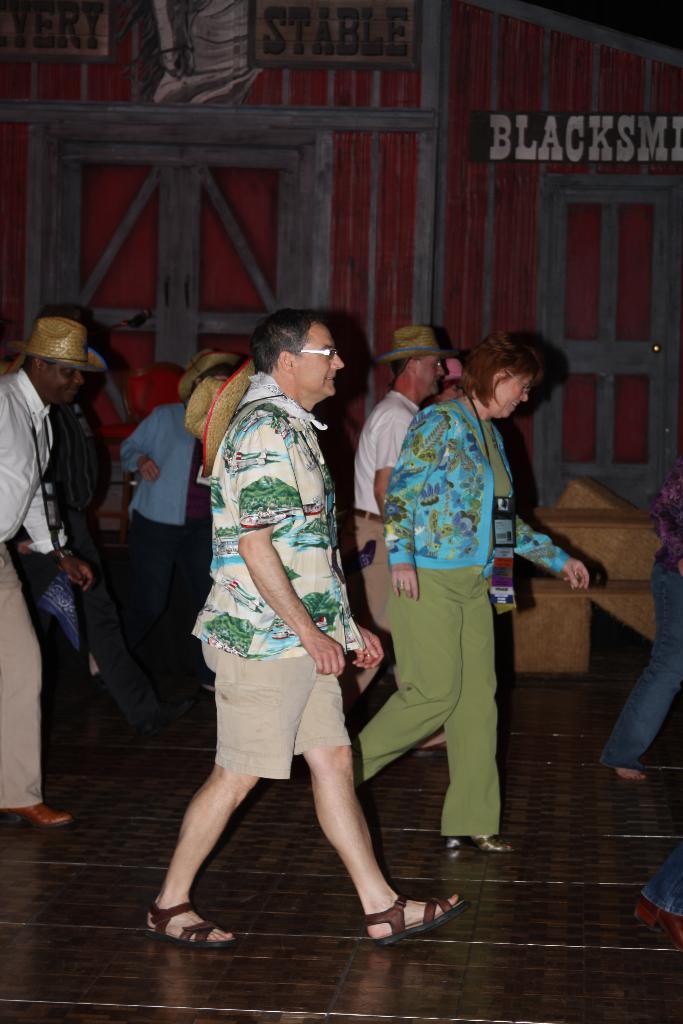Could you give a brief overview of what you see in this image? In the picture we can see some people are walking on the path wearing some hats and colored shirts and in the background, we can see a wooden wall with some door and window painting on it. 